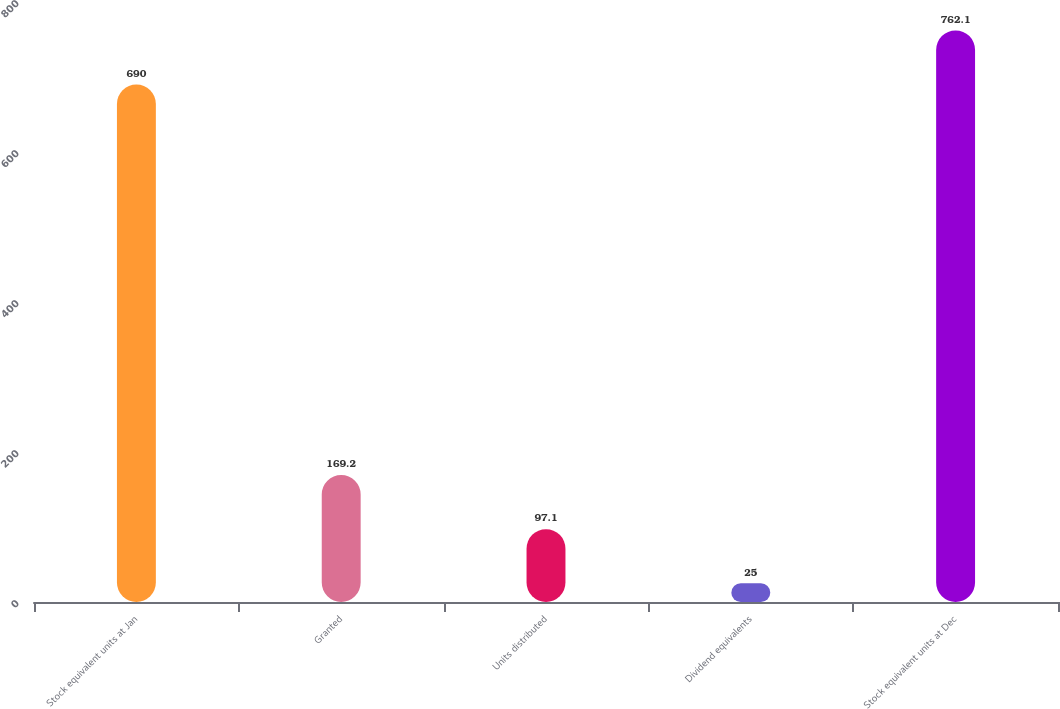<chart> <loc_0><loc_0><loc_500><loc_500><bar_chart><fcel>Stock equivalent units at Jan<fcel>Granted<fcel>Units distributed<fcel>Dividend equivalents<fcel>Stock equivalent units at Dec<nl><fcel>690<fcel>169.2<fcel>97.1<fcel>25<fcel>762.1<nl></chart> 